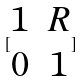<formula> <loc_0><loc_0><loc_500><loc_500>[ \begin{matrix} 1 & R \\ 0 & 1 \end{matrix} ]</formula> 